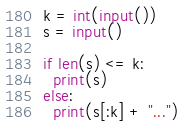<code> <loc_0><loc_0><loc_500><loc_500><_Python_>k = int(input())
s = input()

if len(s) <= k:
  print(s)
else:
  print(s[:k] + "...")</code> 